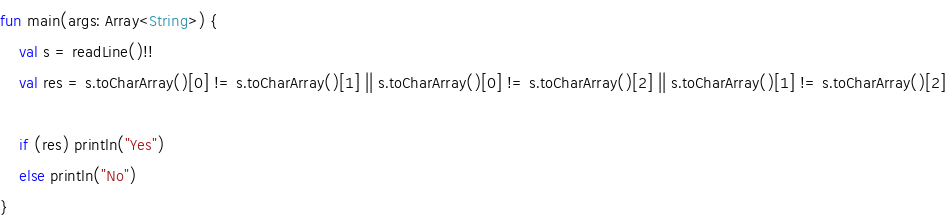Convert code to text. <code><loc_0><loc_0><loc_500><loc_500><_Kotlin_>fun main(args: Array<String>) {
    val s = readLine()!!
    val res = s.toCharArray()[0] != s.toCharArray()[1] || s.toCharArray()[0] != s.toCharArray()[2] || s.toCharArray()[1] != s.toCharArray()[2]

    if (res) println("Yes")
    else println("No")
}
</code> 